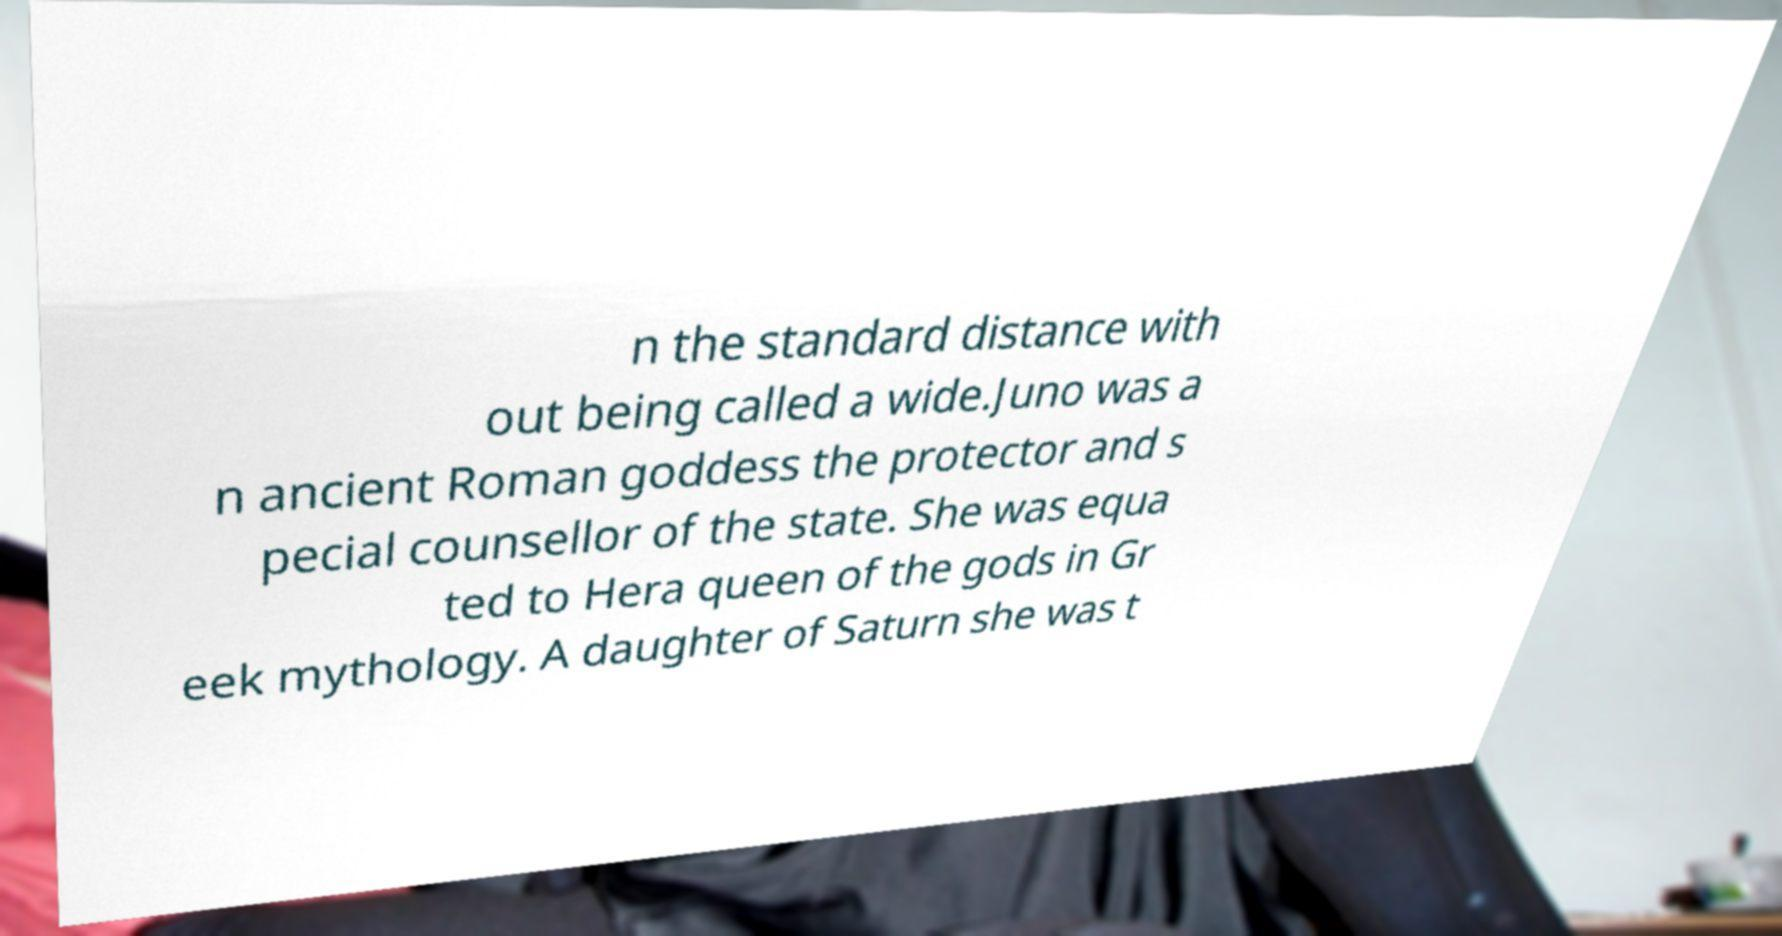I need the written content from this picture converted into text. Can you do that? n the standard distance with out being called a wide.Juno was a n ancient Roman goddess the protector and s pecial counsellor of the state. She was equa ted to Hera queen of the gods in Gr eek mythology. A daughter of Saturn she was t 